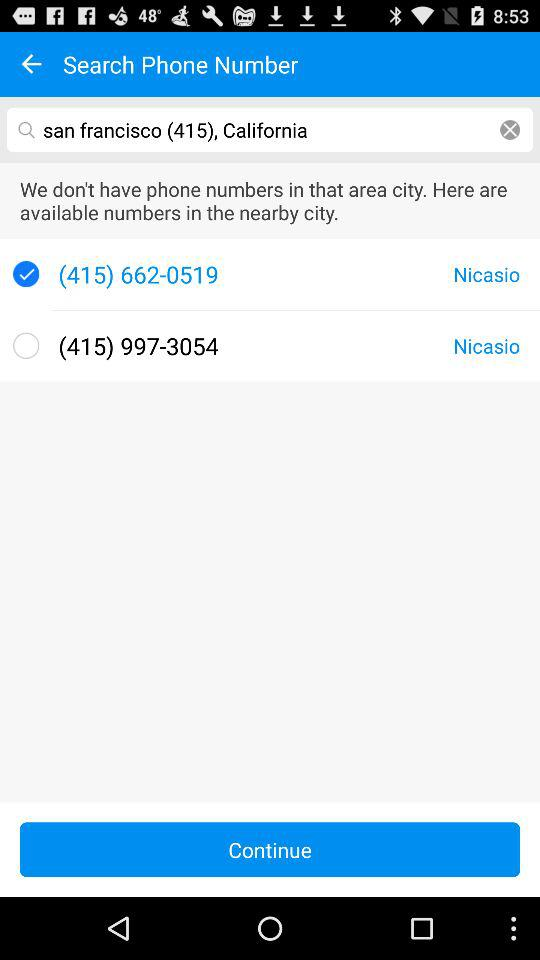Which location's phone number has been searched? The location is San Francisco, California. 